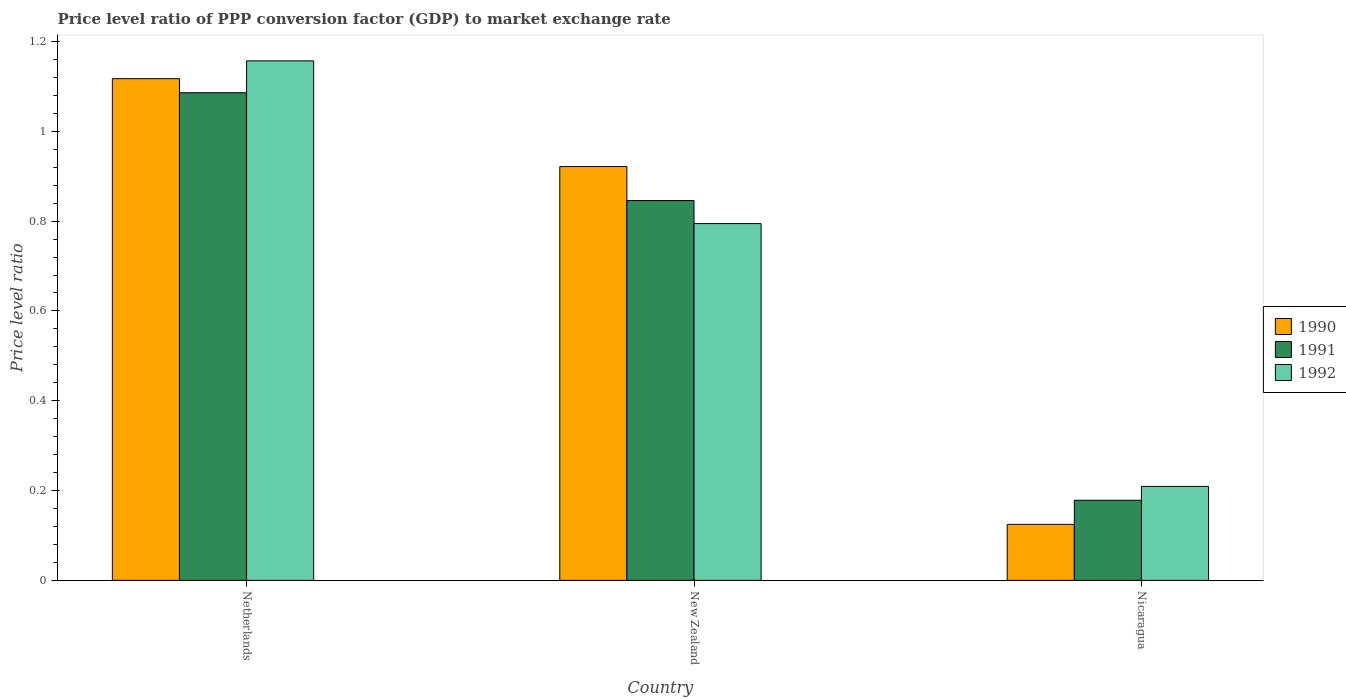How many groups of bars are there?
Your answer should be very brief. 3. Are the number of bars per tick equal to the number of legend labels?
Provide a succinct answer. Yes. Are the number of bars on each tick of the X-axis equal?
Keep it short and to the point. Yes. How many bars are there on the 3rd tick from the left?
Keep it short and to the point. 3. How many bars are there on the 1st tick from the right?
Offer a terse response. 3. What is the label of the 3rd group of bars from the left?
Your response must be concise. Nicaragua. What is the price level ratio in 1992 in Netherlands?
Offer a terse response. 1.16. Across all countries, what is the maximum price level ratio in 1990?
Give a very brief answer. 1.12. Across all countries, what is the minimum price level ratio in 1991?
Your response must be concise. 0.18. In which country was the price level ratio in 1991 minimum?
Provide a short and direct response. Nicaragua. What is the total price level ratio in 1990 in the graph?
Offer a very short reply. 2.16. What is the difference between the price level ratio in 1990 in New Zealand and that in Nicaragua?
Your answer should be very brief. 0.8. What is the difference between the price level ratio in 1990 in Netherlands and the price level ratio in 1991 in New Zealand?
Make the answer very short. 0.27. What is the average price level ratio in 1990 per country?
Offer a very short reply. 0.72. What is the difference between the price level ratio of/in 1990 and price level ratio of/in 1992 in Nicaragua?
Offer a terse response. -0.08. In how many countries, is the price level ratio in 1991 greater than 1.08?
Your answer should be very brief. 1. What is the ratio of the price level ratio in 1991 in Netherlands to that in Nicaragua?
Offer a very short reply. 6.09. Is the price level ratio in 1990 in Netherlands less than that in Nicaragua?
Provide a short and direct response. No. Is the difference between the price level ratio in 1990 in Netherlands and New Zealand greater than the difference between the price level ratio in 1992 in Netherlands and New Zealand?
Your answer should be very brief. No. What is the difference between the highest and the second highest price level ratio in 1990?
Your answer should be compact. -0.2. What is the difference between the highest and the lowest price level ratio in 1991?
Provide a short and direct response. 0.91. Is the sum of the price level ratio in 1991 in New Zealand and Nicaragua greater than the maximum price level ratio in 1992 across all countries?
Give a very brief answer. No. Is it the case that in every country, the sum of the price level ratio in 1992 and price level ratio in 1990 is greater than the price level ratio in 1991?
Offer a terse response. Yes. How many bars are there?
Your answer should be very brief. 9. Are all the bars in the graph horizontal?
Give a very brief answer. No. Are the values on the major ticks of Y-axis written in scientific E-notation?
Provide a short and direct response. No. Does the graph contain grids?
Offer a very short reply. No. How are the legend labels stacked?
Your answer should be very brief. Vertical. What is the title of the graph?
Make the answer very short. Price level ratio of PPP conversion factor (GDP) to market exchange rate. What is the label or title of the Y-axis?
Offer a very short reply. Price level ratio. What is the Price level ratio of 1990 in Netherlands?
Your answer should be very brief. 1.12. What is the Price level ratio in 1991 in Netherlands?
Offer a terse response. 1.09. What is the Price level ratio of 1992 in Netherlands?
Offer a terse response. 1.16. What is the Price level ratio of 1990 in New Zealand?
Provide a succinct answer. 0.92. What is the Price level ratio of 1991 in New Zealand?
Keep it short and to the point. 0.85. What is the Price level ratio of 1992 in New Zealand?
Your answer should be very brief. 0.79. What is the Price level ratio of 1990 in Nicaragua?
Your answer should be compact. 0.12. What is the Price level ratio of 1991 in Nicaragua?
Offer a very short reply. 0.18. What is the Price level ratio of 1992 in Nicaragua?
Make the answer very short. 0.21. Across all countries, what is the maximum Price level ratio in 1990?
Give a very brief answer. 1.12. Across all countries, what is the maximum Price level ratio in 1991?
Keep it short and to the point. 1.09. Across all countries, what is the maximum Price level ratio in 1992?
Offer a terse response. 1.16. Across all countries, what is the minimum Price level ratio of 1990?
Make the answer very short. 0.12. Across all countries, what is the minimum Price level ratio of 1991?
Offer a terse response. 0.18. Across all countries, what is the minimum Price level ratio of 1992?
Ensure brevity in your answer.  0.21. What is the total Price level ratio of 1990 in the graph?
Offer a terse response. 2.16. What is the total Price level ratio in 1991 in the graph?
Keep it short and to the point. 2.11. What is the total Price level ratio of 1992 in the graph?
Offer a terse response. 2.16. What is the difference between the Price level ratio in 1990 in Netherlands and that in New Zealand?
Keep it short and to the point. 0.2. What is the difference between the Price level ratio in 1991 in Netherlands and that in New Zealand?
Ensure brevity in your answer.  0.24. What is the difference between the Price level ratio in 1992 in Netherlands and that in New Zealand?
Make the answer very short. 0.36. What is the difference between the Price level ratio of 1991 in Netherlands and that in Nicaragua?
Provide a short and direct response. 0.91. What is the difference between the Price level ratio of 1992 in Netherlands and that in Nicaragua?
Provide a succinct answer. 0.95. What is the difference between the Price level ratio in 1990 in New Zealand and that in Nicaragua?
Offer a very short reply. 0.8. What is the difference between the Price level ratio in 1991 in New Zealand and that in Nicaragua?
Your response must be concise. 0.67. What is the difference between the Price level ratio in 1992 in New Zealand and that in Nicaragua?
Your answer should be compact. 0.59. What is the difference between the Price level ratio of 1990 in Netherlands and the Price level ratio of 1991 in New Zealand?
Offer a very short reply. 0.27. What is the difference between the Price level ratio of 1990 in Netherlands and the Price level ratio of 1992 in New Zealand?
Your answer should be compact. 0.32. What is the difference between the Price level ratio of 1991 in Netherlands and the Price level ratio of 1992 in New Zealand?
Your answer should be compact. 0.29. What is the difference between the Price level ratio in 1990 in Netherlands and the Price level ratio in 1991 in Nicaragua?
Keep it short and to the point. 0.94. What is the difference between the Price level ratio of 1990 in Netherlands and the Price level ratio of 1992 in Nicaragua?
Provide a short and direct response. 0.91. What is the difference between the Price level ratio in 1991 in Netherlands and the Price level ratio in 1992 in Nicaragua?
Ensure brevity in your answer.  0.88. What is the difference between the Price level ratio in 1990 in New Zealand and the Price level ratio in 1991 in Nicaragua?
Offer a terse response. 0.74. What is the difference between the Price level ratio of 1990 in New Zealand and the Price level ratio of 1992 in Nicaragua?
Offer a very short reply. 0.71. What is the difference between the Price level ratio of 1991 in New Zealand and the Price level ratio of 1992 in Nicaragua?
Make the answer very short. 0.64. What is the average Price level ratio in 1990 per country?
Your answer should be compact. 0.72. What is the average Price level ratio of 1991 per country?
Provide a short and direct response. 0.7. What is the average Price level ratio in 1992 per country?
Your answer should be compact. 0.72. What is the difference between the Price level ratio in 1990 and Price level ratio in 1991 in Netherlands?
Keep it short and to the point. 0.03. What is the difference between the Price level ratio of 1990 and Price level ratio of 1992 in Netherlands?
Ensure brevity in your answer.  -0.04. What is the difference between the Price level ratio of 1991 and Price level ratio of 1992 in Netherlands?
Keep it short and to the point. -0.07. What is the difference between the Price level ratio of 1990 and Price level ratio of 1991 in New Zealand?
Make the answer very short. 0.08. What is the difference between the Price level ratio in 1990 and Price level ratio in 1992 in New Zealand?
Your answer should be compact. 0.13. What is the difference between the Price level ratio of 1991 and Price level ratio of 1992 in New Zealand?
Provide a short and direct response. 0.05. What is the difference between the Price level ratio in 1990 and Price level ratio in 1991 in Nicaragua?
Your answer should be very brief. -0.05. What is the difference between the Price level ratio of 1990 and Price level ratio of 1992 in Nicaragua?
Your response must be concise. -0.08. What is the difference between the Price level ratio in 1991 and Price level ratio in 1992 in Nicaragua?
Give a very brief answer. -0.03. What is the ratio of the Price level ratio in 1990 in Netherlands to that in New Zealand?
Offer a very short reply. 1.21. What is the ratio of the Price level ratio in 1991 in Netherlands to that in New Zealand?
Provide a short and direct response. 1.28. What is the ratio of the Price level ratio in 1992 in Netherlands to that in New Zealand?
Your response must be concise. 1.46. What is the ratio of the Price level ratio of 1990 in Netherlands to that in Nicaragua?
Provide a short and direct response. 8.95. What is the ratio of the Price level ratio in 1991 in Netherlands to that in Nicaragua?
Provide a succinct answer. 6.09. What is the ratio of the Price level ratio in 1992 in Netherlands to that in Nicaragua?
Provide a short and direct response. 5.53. What is the ratio of the Price level ratio in 1990 in New Zealand to that in Nicaragua?
Ensure brevity in your answer.  7.38. What is the ratio of the Price level ratio in 1991 in New Zealand to that in Nicaragua?
Ensure brevity in your answer.  4.74. What is the ratio of the Price level ratio of 1992 in New Zealand to that in Nicaragua?
Offer a very short reply. 3.8. What is the difference between the highest and the second highest Price level ratio of 1990?
Provide a short and direct response. 0.2. What is the difference between the highest and the second highest Price level ratio in 1991?
Offer a terse response. 0.24. What is the difference between the highest and the second highest Price level ratio of 1992?
Provide a short and direct response. 0.36. What is the difference between the highest and the lowest Price level ratio in 1991?
Offer a very short reply. 0.91. What is the difference between the highest and the lowest Price level ratio in 1992?
Your answer should be compact. 0.95. 